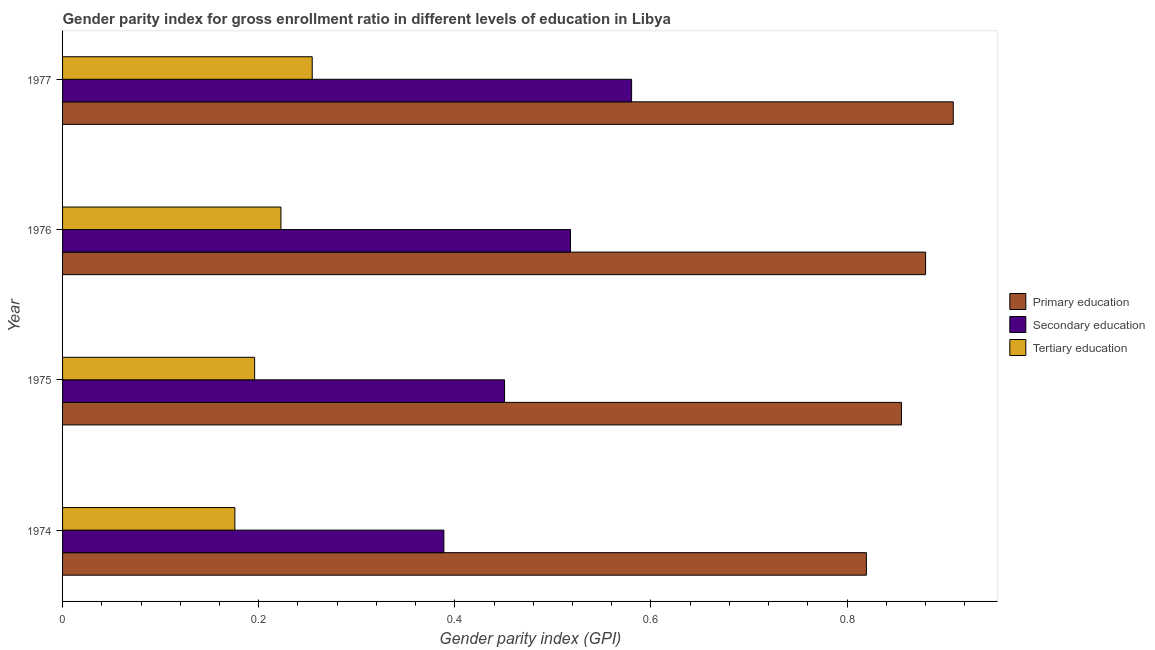How many different coloured bars are there?
Make the answer very short. 3. Are the number of bars on each tick of the Y-axis equal?
Give a very brief answer. Yes. How many bars are there on the 1st tick from the bottom?
Provide a short and direct response. 3. What is the label of the 1st group of bars from the top?
Give a very brief answer. 1977. What is the gender parity index in secondary education in 1975?
Your response must be concise. 0.45. Across all years, what is the maximum gender parity index in secondary education?
Your answer should be compact. 0.58. Across all years, what is the minimum gender parity index in secondary education?
Offer a very short reply. 0.39. In which year was the gender parity index in secondary education maximum?
Ensure brevity in your answer.  1977. In which year was the gender parity index in primary education minimum?
Make the answer very short. 1974. What is the total gender parity index in tertiary education in the graph?
Keep it short and to the point. 0.85. What is the difference between the gender parity index in tertiary education in 1974 and that in 1975?
Offer a terse response. -0.02. What is the difference between the gender parity index in secondary education in 1974 and the gender parity index in primary education in 1977?
Provide a succinct answer. -0.52. What is the average gender parity index in primary education per year?
Your answer should be compact. 0.87. In the year 1976, what is the difference between the gender parity index in secondary education and gender parity index in primary education?
Offer a terse response. -0.36. In how many years, is the gender parity index in secondary education greater than 0.48000000000000004 ?
Provide a succinct answer. 2. What is the ratio of the gender parity index in tertiary education in 1974 to that in 1977?
Offer a terse response. 0.69. Is the gender parity index in secondary education in 1974 less than that in 1975?
Give a very brief answer. Yes. What is the difference between the highest and the second highest gender parity index in primary education?
Make the answer very short. 0.03. What does the 2nd bar from the top in 1976 represents?
Give a very brief answer. Secondary education. What does the 2nd bar from the bottom in 1975 represents?
Your answer should be compact. Secondary education. Are all the bars in the graph horizontal?
Offer a terse response. Yes. How many years are there in the graph?
Ensure brevity in your answer.  4. What is the difference between two consecutive major ticks on the X-axis?
Your answer should be compact. 0.2. Does the graph contain grids?
Make the answer very short. No. Where does the legend appear in the graph?
Provide a succinct answer. Center right. How are the legend labels stacked?
Give a very brief answer. Vertical. What is the title of the graph?
Provide a succinct answer. Gender parity index for gross enrollment ratio in different levels of education in Libya. What is the label or title of the X-axis?
Give a very brief answer. Gender parity index (GPI). What is the label or title of the Y-axis?
Your answer should be very brief. Year. What is the Gender parity index (GPI) in Primary education in 1974?
Give a very brief answer. 0.82. What is the Gender parity index (GPI) in Secondary education in 1974?
Your response must be concise. 0.39. What is the Gender parity index (GPI) of Tertiary education in 1974?
Provide a short and direct response. 0.18. What is the Gender parity index (GPI) of Primary education in 1975?
Ensure brevity in your answer.  0.86. What is the Gender parity index (GPI) of Secondary education in 1975?
Give a very brief answer. 0.45. What is the Gender parity index (GPI) in Tertiary education in 1975?
Offer a terse response. 0.2. What is the Gender parity index (GPI) of Primary education in 1976?
Give a very brief answer. 0.88. What is the Gender parity index (GPI) of Secondary education in 1976?
Provide a succinct answer. 0.52. What is the Gender parity index (GPI) in Tertiary education in 1976?
Your answer should be compact. 0.22. What is the Gender parity index (GPI) in Primary education in 1977?
Provide a succinct answer. 0.91. What is the Gender parity index (GPI) of Secondary education in 1977?
Offer a very short reply. 0.58. What is the Gender parity index (GPI) of Tertiary education in 1977?
Your answer should be compact. 0.25. Across all years, what is the maximum Gender parity index (GPI) in Primary education?
Your response must be concise. 0.91. Across all years, what is the maximum Gender parity index (GPI) in Secondary education?
Your answer should be very brief. 0.58. Across all years, what is the maximum Gender parity index (GPI) in Tertiary education?
Offer a very short reply. 0.25. Across all years, what is the minimum Gender parity index (GPI) in Primary education?
Provide a succinct answer. 0.82. Across all years, what is the minimum Gender parity index (GPI) in Secondary education?
Provide a succinct answer. 0.39. Across all years, what is the minimum Gender parity index (GPI) in Tertiary education?
Make the answer very short. 0.18. What is the total Gender parity index (GPI) in Primary education in the graph?
Provide a succinct answer. 3.46. What is the total Gender parity index (GPI) of Secondary education in the graph?
Ensure brevity in your answer.  1.94. What is the total Gender parity index (GPI) of Tertiary education in the graph?
Provide a short and direct response. 0.85. What is the difference between the Gender parity index (GPI) in Primary education in 1974 and that in 1975?
Provide a short and direct response. -0.04. What is the difference between the Gender parity index (GPI) of Secondary education in 1974 and that in 1975?
Your answer should be very brief. -0.06. What is the difference between the Gender parity index (GPI) of Tertiary education in 1974 and that in 1975?
Offer a terse response. -0.02. What is the difference between the Gender parity index (GPI) in Primary education in 1974 and that in 1976?
Make the answer very short. -0.06. What is the difference between the Gender parity index (GPI) of Secondary education in 1974 and that in 1976?
Offer a very short reply. -0.13. What is the difference between the Gender parity index (GPI) in Tertiary education in 1974 and that in 1976?
Provide a short and direct response. -0.05. What is the difference between the Gender parity index (GPI) of Primary education in 1974 and that in 1977?
Offer a very short reply. -0.09. What is the difference between the Gender parity index (GPI) of Secondary education in 1974 and that in 1977?
Make the answer very short. -0.19. What is the difference between the Gender parity index (GPI) in Tertiary education in 1974 and that in 1977?
Give a very brief answer. -0.08. What is the difference between the Gender parity index (GPI) in Primary education in 1975 and that in 1976?
Your answer should be very brief. -0.02. What is the difference between the Gender parity index (GPI) of Secondary education in 1975 and that in 1976?
Offer a very short reply. -0.07. What is the difference between the Gender parity index (GPI) of Tertiary education in 1975 and that in 1976?
Offer a very short reply. -0.03. What is the difference between the Gender parity index (GPI) of Primary education in 1975 and that in 1977?
Your answer should be compact. -0.05. What is the difference between the Gender parity index (GPI) in Secondary education in 1975 and that in 1977?
Offer a very short reply. -0.13. What is the difference between the Gender parity index (GPI) of Tertiary education in 1975 and that in 1977?
Give a very brief answer. -0.06. What is the difference between the Gender parity index (GPI) in Primary education in 1976 and that in 1977?
Make the answer very short. -0.03. What is the difference between the Gender parity index (GPI) of Secondary education in 1976 and that in 1977?
Keep it short and to the point. -0.06. What is the difference between the Gender parity index (GPI) in Tertiary education in 1976 and that in 1977?
Ensure brevity in your answer.  -0.03. What is the difference between the Gender parity index (GPI) of Primary education in 1974 and the Gender parity index (GPI) of Secondary education in 1975?
Give a very brief answer. 0.37. What is the difference between the Gender parity index (GPI) in Primary education in 1974 and the Gender parity index (GPI) in Tertiary education in 1975?
Your answer should be compact. 0.62. What is the difference between the Gender parity index (GPI) in Secondary education in 1974 and the Gender parity index (GPI) in Tertiary education in 1975?
Make the answer very short. 0.19. What is the difference between the Gender parity index (GPI) of Primary education in 1974 and the Gender parity index (GPI) of Secondary education in 1976?
Give a very brief answer. 0.3. What is the difference between the Gender parity index (GPI) in Primary education in 1974 and the Gender parity index (GPI) in Tertiary education in 1976?
Ensure brevity in your answer.  0.6. What is the difference between the Gender parity index (GPI) in Secondary education in 1974 and the Gender parity index (GPI) in Tertiary education in 1976?
Give a very brief answer. 0.17. What is the difference between the Gender parity index (GPI) in Primary education in 1974 and the Gender parity index (GPI) in Secondary education in 1977?
Offer a terse response. 0.24. What is the difference between the Gender parity index (GPI) in Primary education in 1974 and the Gender parity index (GPI) in Tertiary education in 1977?
Ensure brevity in your answer.  0.57. What is the difference between the Gender parity index (GPI) in Secondary education in 1974 and the Gender parity index (GPI) in Tertiary education in 1977?
Make the answer very short. 0.13. What is the difference between the Gender parity index (GPI) in Primary education in 1975 and the Gender parity index (GPI) in Secondary education in 1976?
Your answer should be compact. 0.34. What is the difference between the Gender parity index (GPI) in Primary education in 1975 and the Gender parity index (GPI) in Tertiary education in 1976?
Give a very brief answer. 0.63. What is the difference between the Gender parity index (GPI) of Secondary education in 1975 and the Gender parity index (GPI) of Tertiary education in 1976?
Provide a short and direct response. 0.23. What is the difference between the Gender parity index (GPI) in Primary education in 1975 and the Gender parity index (GPI) in Secondary education in 1977?
Offer a very short reply. 0.28. What is the difference between the Gender parity index (GPI) in Primary education in 1975 and the Gender parity index (GPI) in Tertiary education in 1977?
Your answer should be compact. 0.6. What is the difference between the Gender parity index (GPI) of Secondary education in 1975 and the Gender parity index (GPI) of Tertiary education in 1977?
Your answer should be compact. 0.2. What is the difference between the Gender parity index (GPI) of Primary education in 1976 and the Gender parity index (GPI) of Secondary education in 1977?
Offer a very short reply. 0.3. What is the difference between the Gender parity index (GPI) of Primary education in 1976 and the Gender parity index (GPI) of Tertiary education in 1977?
Provide a succinct answer. 0.63. What is the difference between the Gender parity index (GPI) of Secondary education in 1976 and the Gender parity index (GPI) of Tertiary education in 1977?
Provide a succinct answer. 0.26. What is the average Gender parity index (GPI) in Primary education per year?
Your response must be concise. 0.87. What is the average Gender parity index (GPI) in Secondary education per year?
Your answer should be compact. 0.48. What is the average Gender parity index (GPI) in Tertiary education per year?
Offer a terse response. 0.21. In the year 1974, what is the difference between the Gender parity index (GPI) of Primary education and Gender parity index (GPI) of Secondary education?
Offer a terse response. 0.43. In the year 1974, what is the difference between the Gender parity index (GPI) of Primary education and Gender parity index (GPI) of Tertiary education?
Offer a very short reply. 0.64. In the year 1974, what is the difference between the Gender parity index (GPI) of Secondary education and Gender parity index (GPI) of Tertiary education?
Your response must be concise. 0.21. In the year 1975, what is the difference between the Gender parity index (GPI) of Primary education and Gender parity index (GPI) of Secondary education?
Keep it short and to the point. 0.4. In the year 1975, what is the difference between the Gender parity index (GPI) of Primary education and Gender parity index (GPI) of Tertiary education?
Provide a succinct answer. 0.66. In the year 1975, what is the difference between the Gender parity index (GPI) in Secondary education and Gender parity index (GPI) in Tertiary education?
Keep it short and to the point. 0.25. In the year 1976, what is the difference between the Gender parity index (GPI) of Primary education and Gender parity index (GPI) of Secondary education?
Provide a succinct answer. 0.36. In the year 1976, what is the difference between the Gender parity index (GPI) of Primary education and Gender parity index (GPI) of Tertiary education?
Keep it short and to the point. 0.66. In the year 1976, what is the difference between the Gender parity index (GPI) of Secondary education and Gender parity index (GPI) of Tertiary education?
Give a very brief answer. 0.3. In the year 1977, what is the difference between the Gender parity index (GPI) in Primary education and Gender parity index (GPI) in Secondary education?
Offer a very short reply. 0.33. In the year 1977, what is the difference between the Gender parity index (GPI) in Primary education and Gender parity index (GPI) in Tertiary education?
Your answer should be compact. 0.65. In the year 1977, what is the difference between the Gender parity index (GPI) in Secondary education and Gender parity index (GPI) in Tertiary education?
Offer a very short reply. 0.33. What is the ratio of the Gender parity index (GPI) in Primary education in 1974 to that in 1975?
Your response must be concise. 0.96. What is the ratio of the Gender parity index (GPI) of Secondary education in 1974 to that in 1975?
Your answer should be very brief. 0.86. What is the ratio of the Gender parity index (GPI) in Tertiary education in 1974 to that in 1975?
Your response must be concise. 0.9. What is the ratio of the Gender parity index (GPI) in Primary education in 1974 to that in 1976?
Offer a terse response. 0.93. What is the ratio of the Gender parity index (GPI) in Secondary education in 1974 to that in 1976?
Ensure brevity in your answer.  0.75. What is the ratio of the Gender parity index (GPI) in Tertiary education in 1974 to that in 1976?
Make the answer very short. 0.79. What is the ratio of the Gender parity index (GPI) in Primary education in 1974 to that in 1977?
Give a very brief answer. 0.9. What is the ratio of the Gender parity index (GPI) of Secondary education in 1974 to that in 1977?
Keep it short and to the point. 0.67. What is the ratio of the Gender parity index (GPI) in Tertiary education in 1974 to that in 1977?
Your answer should be very brief. 0.69. What is the ratio of the Gender parity index (GPI) in Primary education in 1975 to that in 1976?
Your answer should be compact. 0.97. What is the ratio of the Gender parity index (GPI) in Secondary education in 1975 to that in 1976?
Your response must be concise. 0.87. What is the ratio of the Gender parity index (GPI) in Tertiary education in 1975 to that in 1976?
Your answer should be compact. 0.88. What is the ratio of the Gender parity index (GPI) of Primary education in 1975 to that in 1977?
Offer a terse response. 0.94. What is the ratio of the Gender parity index (GPI) of Secondary education in 1975 to that in 1977?
Your answer should be compact. 0.78. What is the ratio of the Gender parity index (GPI) in Tertiary education in 1975 to that in 1977?
Your answer should be compact. 0.77. What is the ratio of the Gender parity index (GPI) of Primary education in 1976 to that in 1977?
Offer a very short reply. 0.97. What is the ratio of the Gender parity index (GPI) in Secondary education in 1976 to that in 1977?
Your response must be concise. 0.89. What is the ratio of the Gender parity index (GPI) in Tertiary education in 1976 to that in 1977?
Keep it short and to the point. 0.87. What is the difference between the highest and the second highest Gender parity index (GPI) of Primary education?
Give a very brief answer. 0.03. What is the difference between the highest and the second highest Gender parity index (GPI) in Secondary education?
Your answer should be compact. 0.06. What is the difference between the highest and the second highest Gender parity index (GPI) of Tertiary education?
Offer a very short reply. 0.03. What is the difference between the highest and the lowest Gender parity index (GPI) in Primary education?
Your response must be concise. 0.09. What is the difference between the highest and the lowest Gender parity index (GPI) in Secondary education?
Keep it short and to the point. 0.19. What is the difference between the highest and the lowest Gender parity index (GPI) of Tertiary education?
Your answer should be very brief. 0.08. 